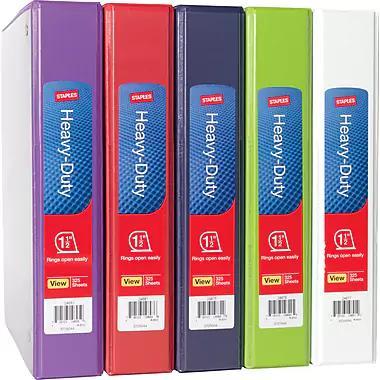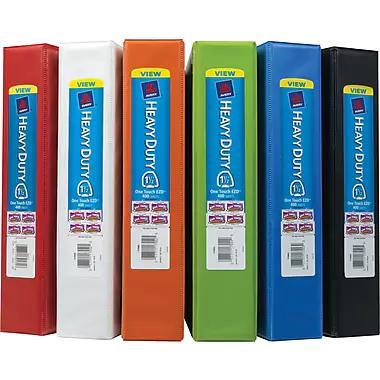The first image is the image on the left, the second image is the image on the right. Evaluate the accuracy of this statement regarding the images: "There is a single binder by itself.". Is it true? Answer yes or no. No. The first image is the image on the left, the second image is the image on the right. Assess this claim about the two images: "There are less than ten binders.". Correct or not? Answer yes or no. No. 